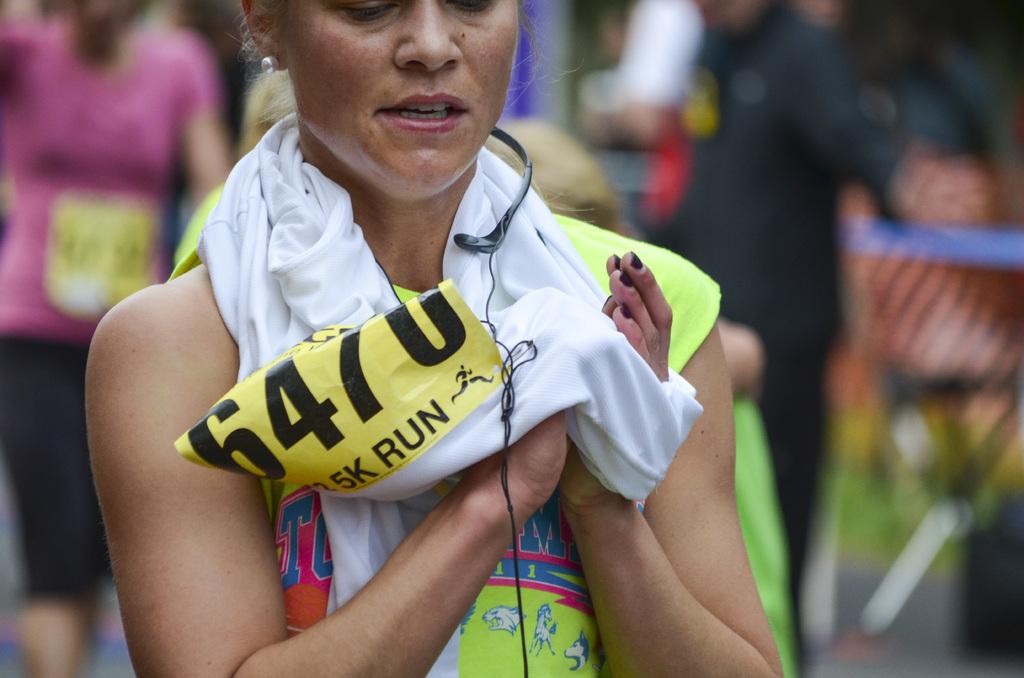What is her race number?
Your answer should be very brief. 6470. 